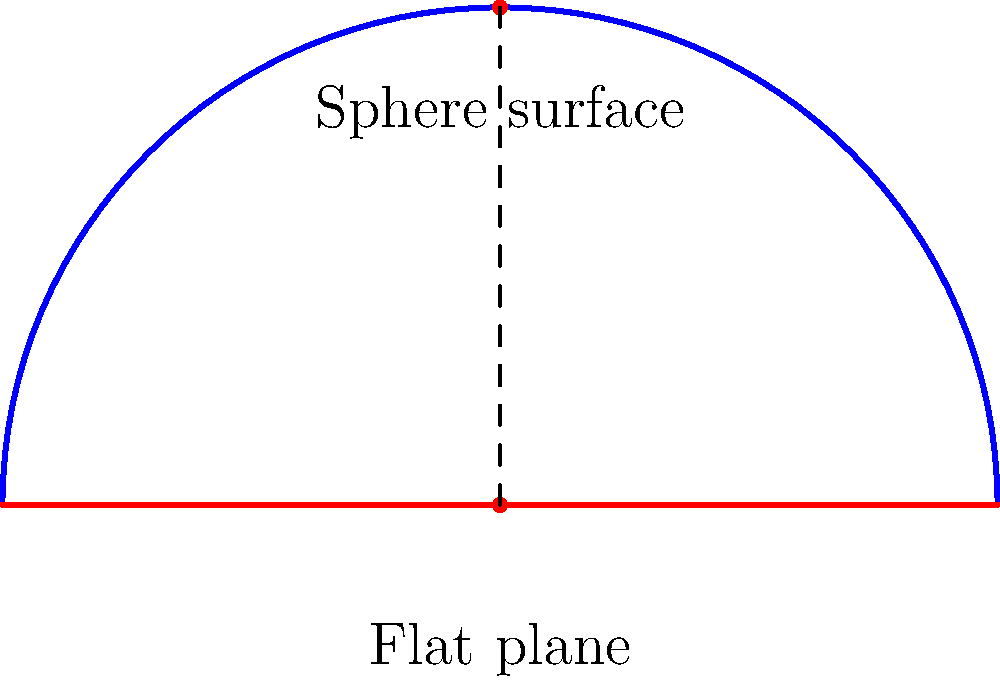In the diagram, the blue arc represents a section of a sphere's surface, while the red line represents a flat plane. If two points are placed at the ends of the blue arc and the red line respectively, how does the distance between these points on the sphere's surface compare to the distance on the flat plane? To understand the difference between the distances on a sphere's surface and a flat plane, let's follow these steps:

1. Observe the diagram: The blue arc represents a section of a sphere's surface, and the red line represents a flat plane.

2. Consider the points: Imagine two points placed at the ends of both the blue arc and the red line.

3. Flat plane distance: On the flat plane (red line), the distance between the points is the straight-line distance, which is the shortest possible path between two points in Euclidean geometry.

4. Sphere surface distance: On the sphere's surface (blue arc), the distance between the points follows the curvature of the sphere. This path, known as a great circle arc, is longer than the straight-line distance.

5. Curvature effect: The curvature of the sphere's surface causes the distance between points to be greater than it would be on a flat plane.

6. Non-Euclidean geometry: This difference in distances is a fundamental aspect of non-Euclidean geometry, specifically spherical geometry.

7. Conclusion: The distance between two points on a sphere's surface is always greater than the distance between the same two points on a flat plane, unless the points are infinitesimally close.

This visualization helps to understand why map projections (which attempt to represent the Earth's spherical surface on a flat plane) always involve some form of distortion in either distance, area, or shape.
Answer: The distance on the sphere's surface is greater than on the flat plane. 